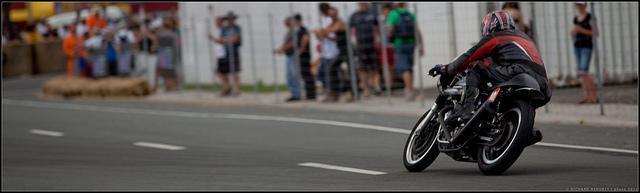Why is the rider's head covered?
Choose the correct response, then elucidate: 'Answer: answer
Rationale: rationale.'
Options: Fashion, protection, religion, warmth. Answer: protection.
Rationale: The helmet protects. 